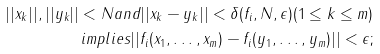Convert formula to latex. <formula><loc_0><loc_0><loc_500><loc_500>| | x _ { k } | | , | | y _ { k } | | < N a n d | | x _ { k } - y _ { k } | | < \delta ( f _ { i } , N , \epsilon ) ( 1 \leq k \leq m ) \\ i m p l i e s | | f _ { i } ( x _ { 1 } , \dots , x _ { m } ) - f _ { i } ( y _ { 1 } , \dots , y _ { m } ) | | < \epsilon ;</formula> 